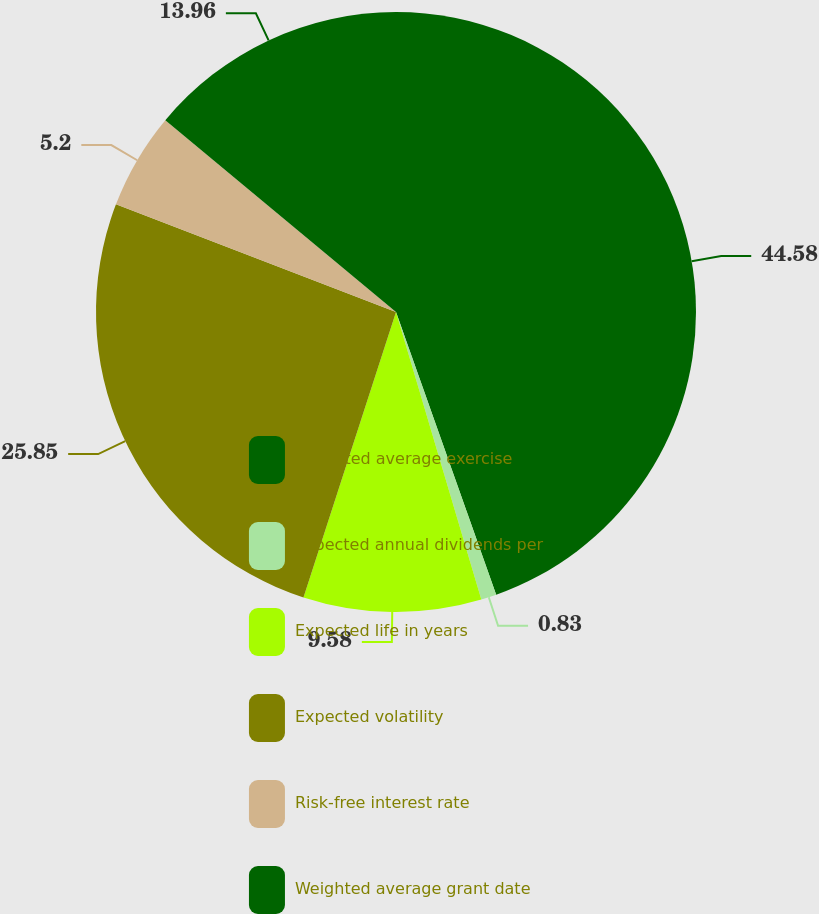Convert chart to OTSL. <chart><loc_0><loc_0><loc_500><loc_500><pie_chart><fcel>Weighted average exercise<fcel>Expected annual dividends per<fcel>Expected life in years<fcel>Expected volatility<fcel>Risk-free interest rate<fcel>Weighted average grant date<nl><fcel>44.58%<fcel>0.83%<fcel>9.58%<fcel>25.85%<fcel>5.2%<fcel>13.96%<nl></chart> 